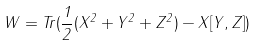Convert formula to latex. <formula><loc_0><loc_0><loc_500><loc_500>W = T r ( \frac { 1 } { 2 } ( X ^ { 2 } + Y ^ { 2 } + Z ^ { 2 } ) - X [ Y , Z ] )</formula> 